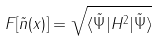Convert formula to latex. <formula><loc_0><loc_0><loc_500><loc_500>F [ \tilde { n } ( x ) ] = \sqrt { \langle \tilde { \Psi } | H ^ { 2 } | \tilde { \Psi } \rangle }</formula> 